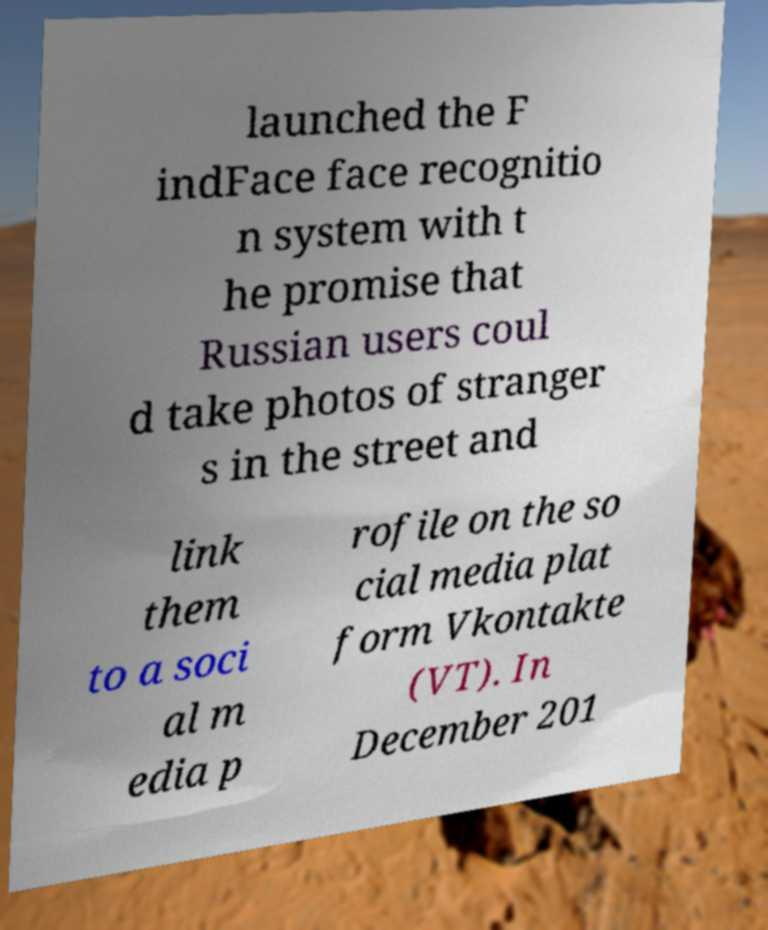There's text embedded in this image that I need extracted. Can you transcribe it verbatim? launched the F indFace face recognitio n system with t he promise that Russian users coul d take photos of stranger s in the street and link them to a soci al m edia p rofile on the so cial media plat form Vkontakte (VT). In December 201 